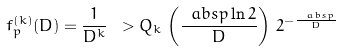<formula> <loc_0><loc_0><loc_500><loc_500>f _ { p } ^ { ( k ) } ( D ) = \frac { 1 } { D ^ { k } } \ > Q _ { k } \, \left ( \frac { \ a b s { p } \ln 2 } { D } \right ) \, 2 ^ { - \frac { \ a b s { p } } { D } }</formula> 